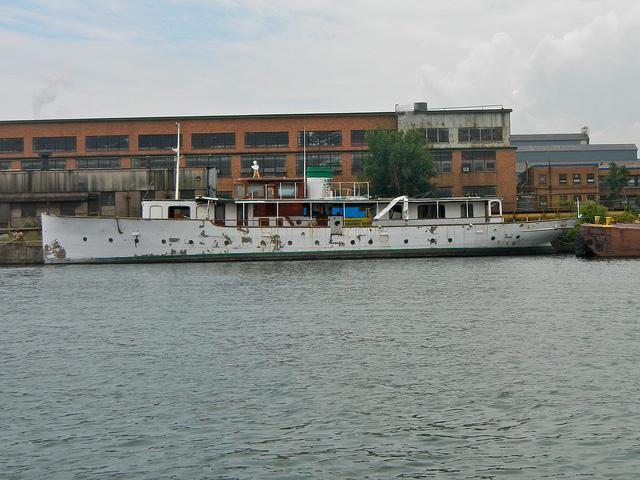Are the boats in motion?
Short answer required. No. How many ships are in the picture?
Short answer required. 1. Does the water appear to be moving?
Answer briefly. Yes. How many white buildings are in the background?
Short answer required. 0. Is the watercraft moving?
Answer briefly. No. What color is the water?
Answer briefly. Blue. How many four pane windows are there on the orange building?
Short answer required. 20. How many boats are there?
Be succinct. 1. Is a man on the roof of the boat?
Concise answer only. Yes. What are the houses for?
Write a very short answer. Living. Is the boat in good condition?
Write a very short answer. No. Does the building only have windows?
Concise answer only. No. 